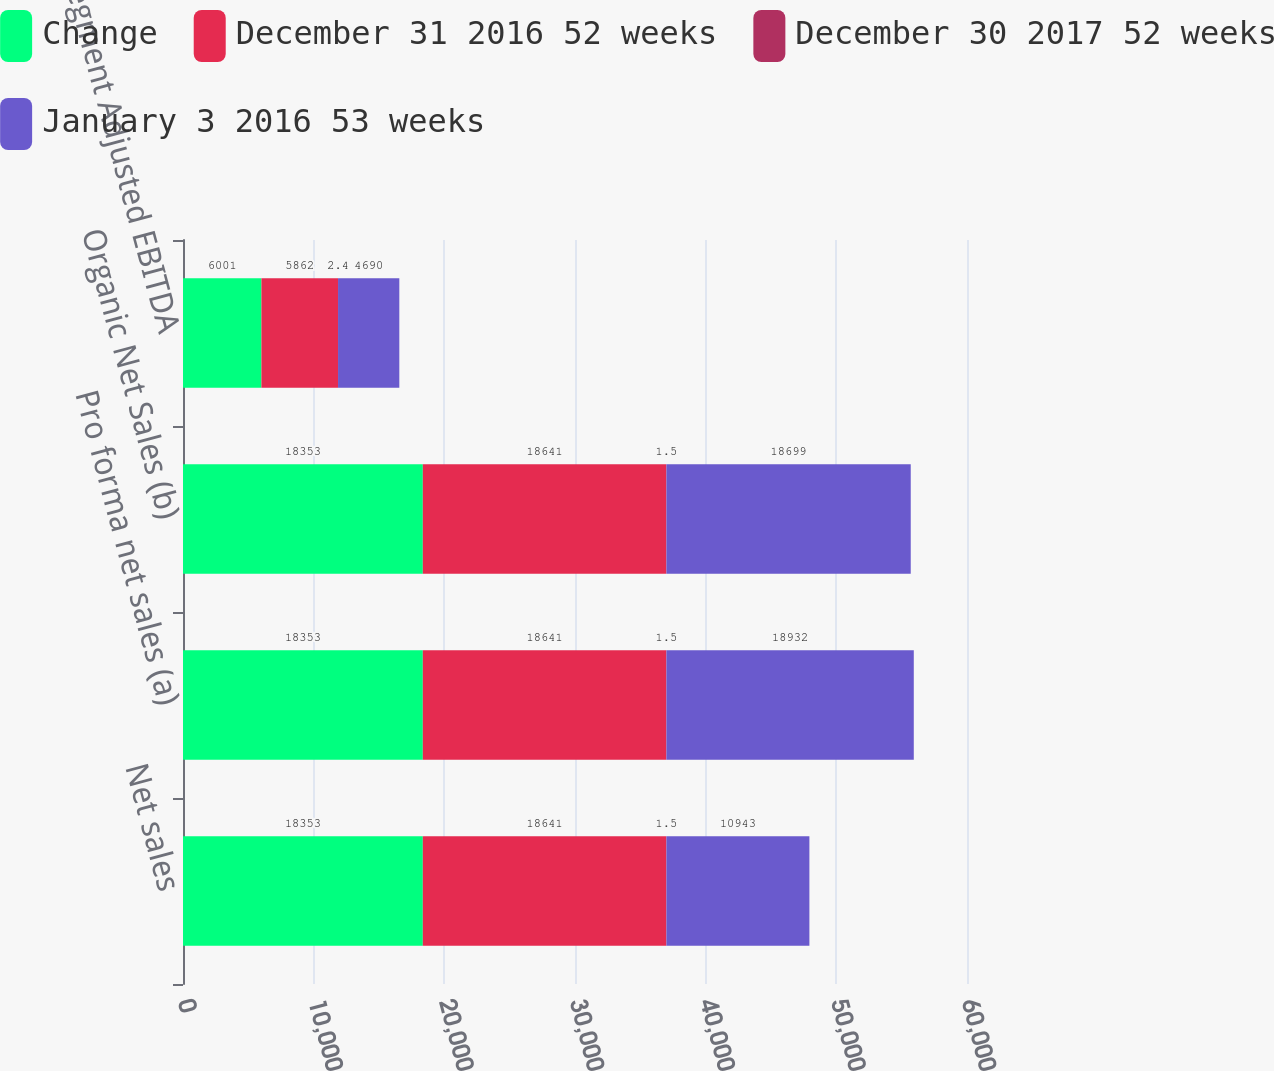<chart> <loc_0><loc_0><loc_500><loc_500><stacked_bar_chart><ecel><fcel>Net sales<fcel>Pro forma net sales (a)<fcel>Organic Net Sales (b)<fcel>Segment Adjusted EBITDA<nl><fcel>Change<fcel>18353<fcel>18353<fcel>18353<fcel>6001<nl><fcel>December 31 2016 52 weeks<fcel>18641<fcel>18641<fcel>18641<fcel>5862<nl><fcel>December 30 2017 52 weeks<fcel>1.5<fcel>1.5<fcel>1.5<fcel>2.4<nl><fcel>January 3 2016 53 weeks<fcel>10943<fcel>18932<fcel>18699<fcel>4690<nl></chart> 